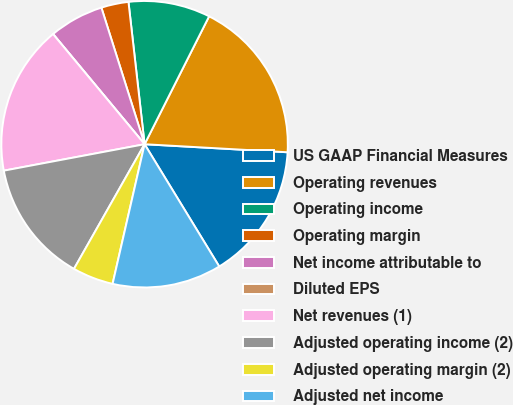Convert chart to OTSL. <chart><loc_0><loc_0><loc_500><loc_500><pie_chart><fcel>US GAAP Financial Measures<fcel>Operating revenues<fcel>Operating income<fcel>Operating margin<fcel>Net income attributable to<fcel>Diluted EPS<fcel>Net revenues (1)<fcel>Adjusted operating income (2)<fcel>Adjusted operating margin (2)<fcel>Adjusted net income<nl><fcel>15.38%<fcel>18.46%<fcel>9.23%<fcel>3.08%<fcel>6.16%<fcel>0.0%<fcel>16.92%<fcel>13.84%<fcel>4.62%<fcel>12.31%<nl></chart> 